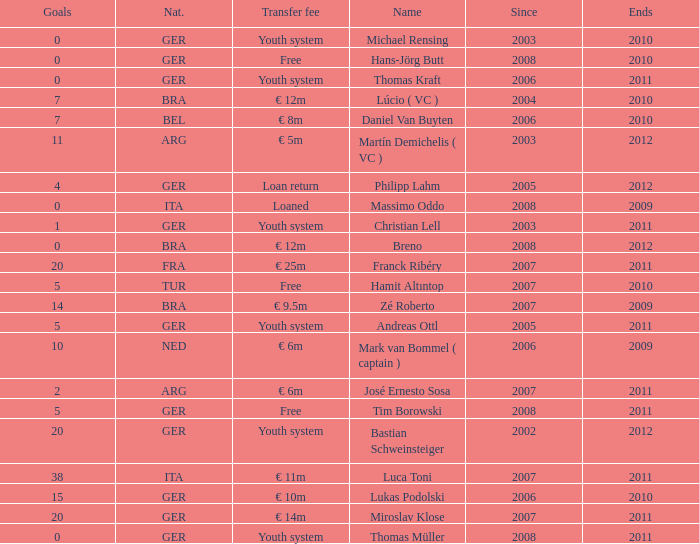What is the total number of ends after 2006 with a nationality of ita and 0 goals? 0.0. 